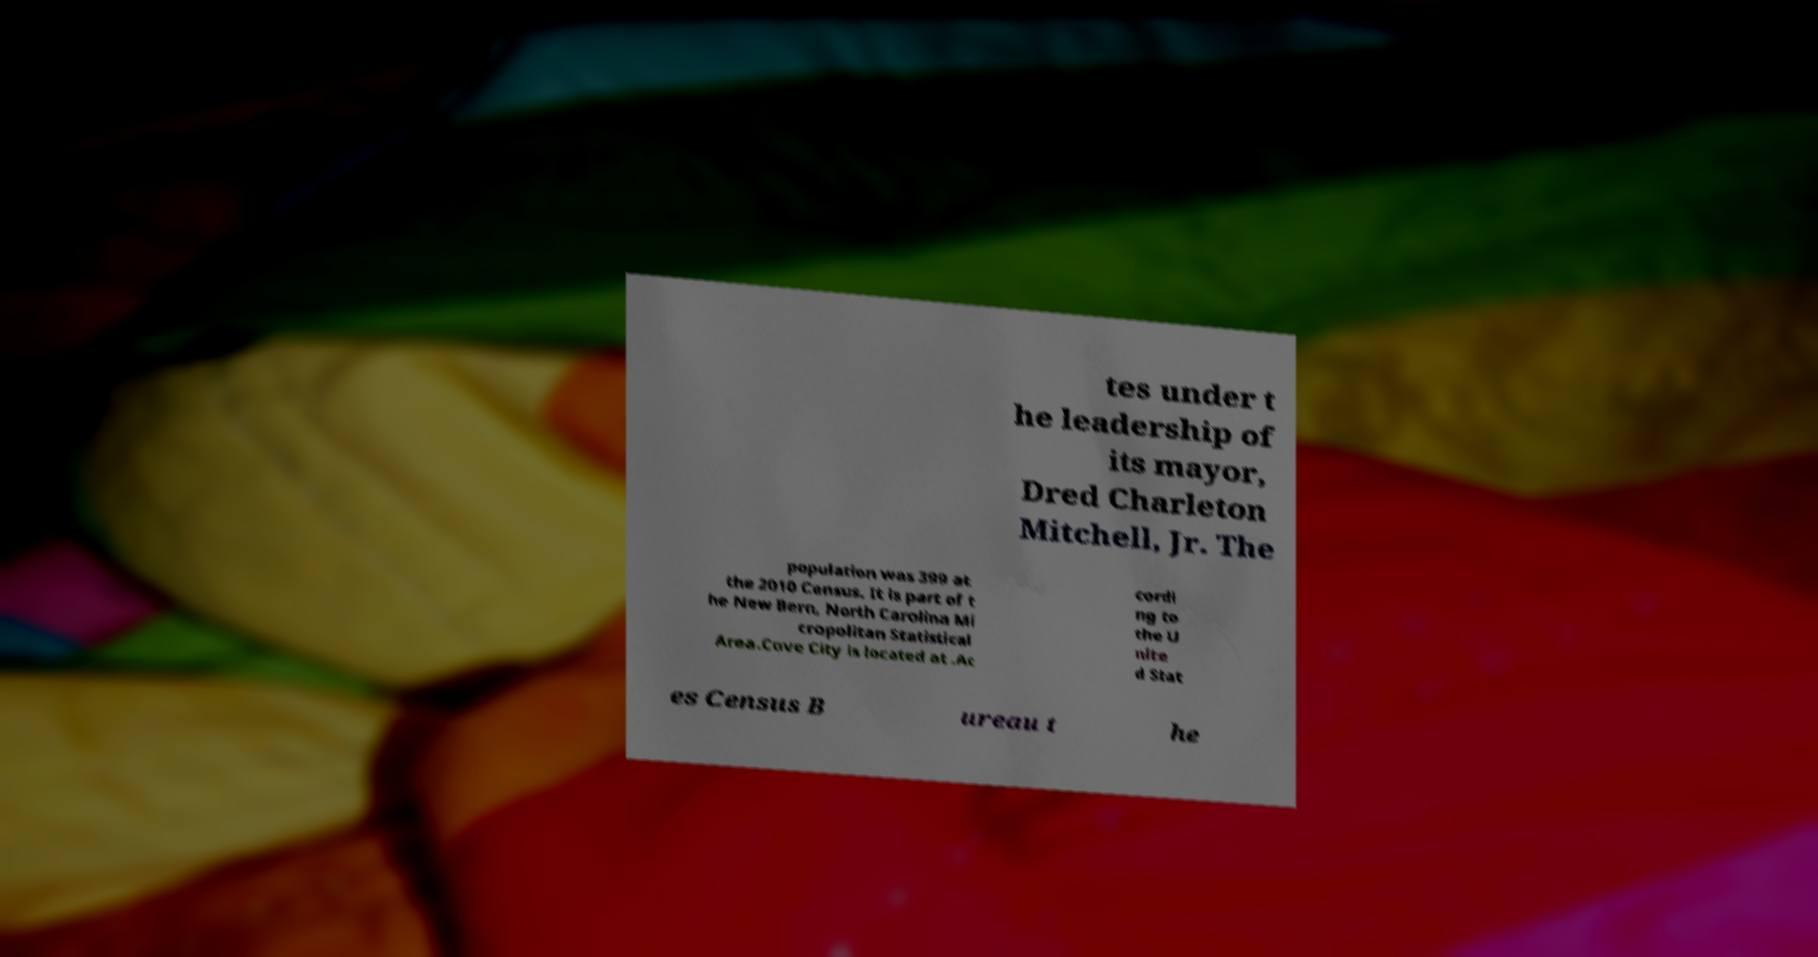Could you assist in decoding the text presented in this image and type it out clearly? tes under t he leadership of its mayor, Dred Charleton Mitchell, Jr. The population was 399 at the 2010 Census. It is part of t he New Bern, North Carolina Mi cropolitan Statistical Area.Cove City is located at .Ac cordi ng to the U nite d Stat es Census B ureau t he 